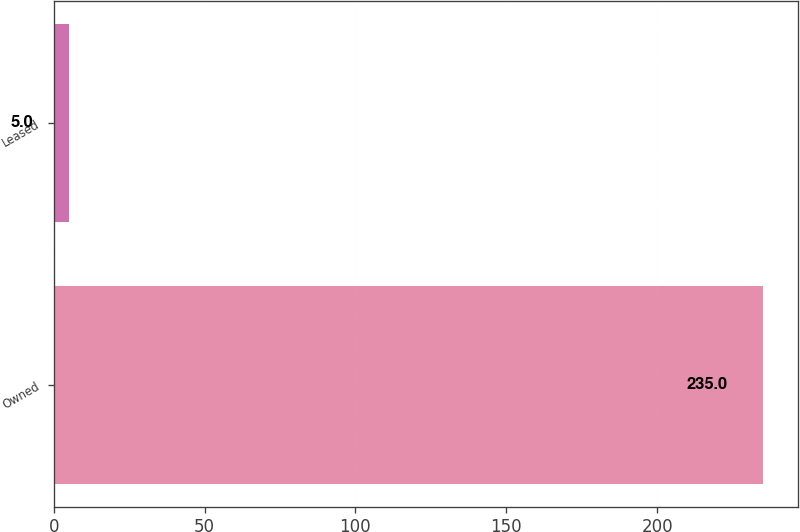<chart> <loc_0><loc_0><loc_500><loc_500><bar_chart><fcel>Owned<fcel>Leased<nl><fcel>235<fcel>5<nl></chart> 